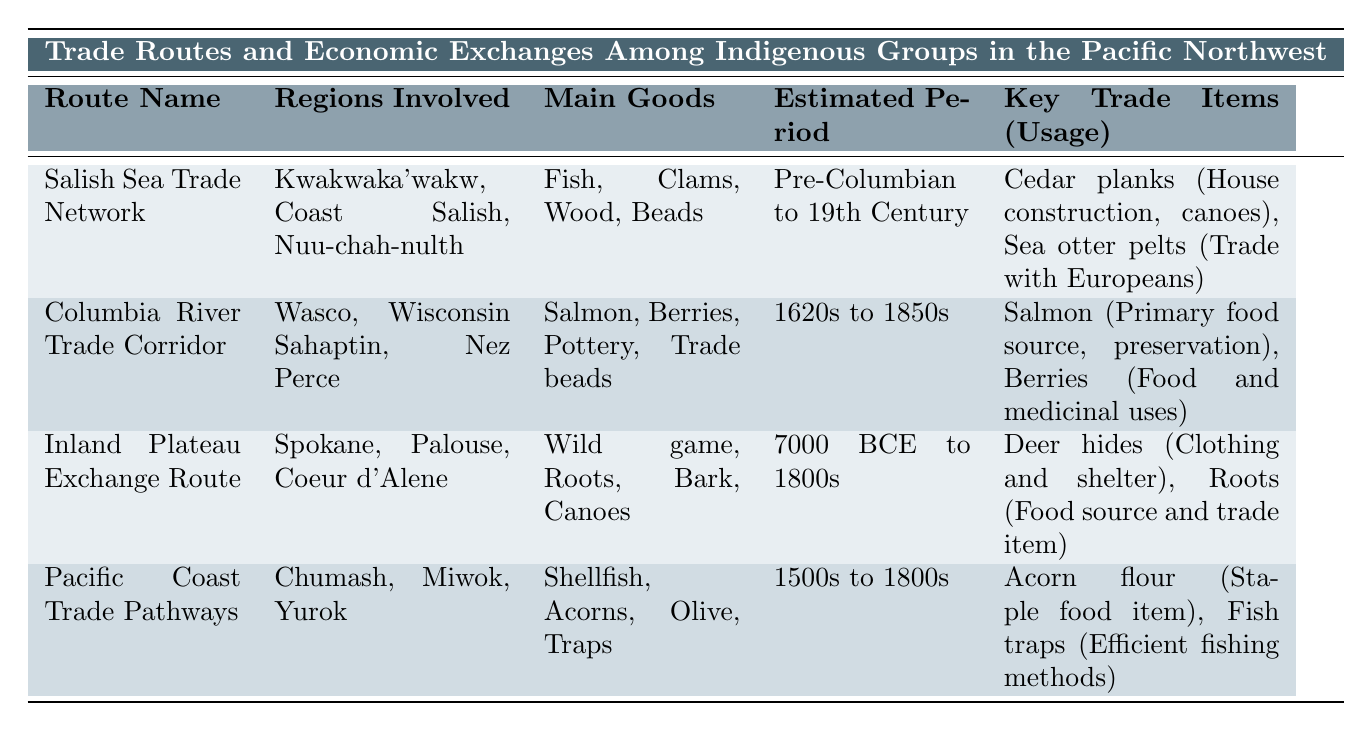What are the main goods traded in the Salish Sea Trade Network? From the table, we can see that the Salish Sea Trade Network lists its main goods as "Fish, Clams, Wood, Beads."
Answer: Fish, Clams, Wood, Beads Which regions were involved in the Columbia River Trade Corridor? The table specifies the regions involved in the Columbia River Trade Corridor as "Wasco, Wisconsin Sahaptin, Nez Perce."
Answer: Wasco, Wisconsin Sahaptin, Nez Perce Did the Inland Plateau Exchange Route operate after the 1800s? The table states that the estimated period for the Inland Plateau Exchange Route is "7000 BCE to 1800s," indicating it did not operate after the 1800s.
Answer: No What is the primary food source traded in the Columbia River Trade Corridor? According to the table, the key trade item for the Columbia River Trade Corridor is "Salmon," which is specifically noted as the primary food source.
Answer: Salmon How many different key trade items are listed for the Pacific Coast Trade Pathways? The Pacific Coast Trade Pathways has two key trade items listed: "Acorn flour" and "Fish traps." Hence, the total is 2.
Answer: 2 Which trade route had the earliest estimated trading period? By comparing the estimated periods in the table, the Inland Plateau Exchange Route, with an estimated period from "7000 BCE to 1800s," is the earliest.
Answer: Inland Plateau Exchange Route What key trade item from the Salish Sea Trade Network is used for canoes? The table indicates that "Cedar planks" are used for "House construction, canoes" under the Salish Sea Trade Network's key trade items.
Answer: Cedar planks How many regions are involved in the Pacific Coast Trade Pathways? The table lists three regions involved: "Chumash, Miwok, Yurok," totaling three regions.
Answer: 3 Which trade route involved potato as a main good? None of the trade routes listed in the table mention potato as a main good, so the answer is no.
Answer: No If we sum the estimated periods for all routes, which route has the longest duration? By analyzing the durations, the Inland Plateau Exchange Route spans approximately 7000 years, making it the longest estimated period compared to others.
Answer: Inland Plateau Exchange Route 